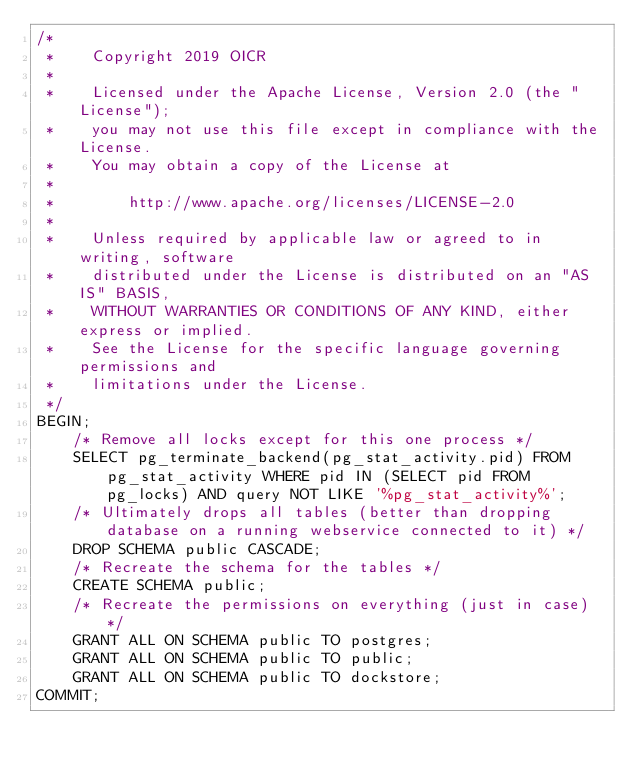<code> <loc_0><loc_0><loc_500><loc_500><_SQL_>/*
 *    Copyright 2019 OICR
 *
 *    Licensed under the Apache License, Version 2.0 (the "License");
 *    you may not use this file except in compliance with the License.
 *    You may obtain a copy of the License at
 *
 *        http://www.apache.org/licenses/LICENSE-2.0
 *
 *    Unless required by applicable law or agreed to in writing, software
 *    distributed under the License is distributed on an "AS IS" BASIS,
 *    WITHOUT WARRANTIES OR CONDITIONS OF ANY KIND, either express or implied.
 *    See the License for the specific language governing permissions and
 *    limitations under the License.
 */
BEGIN;
    /* Remove all locks except for this one process */
    SELECT pg_terminate_backend(pg_stat_activity.pid) FROM pg_stat_activity WHERE pid IN (SELECT pid FROM pg_locks) AND query NOT LIKE '%pg_stat_activity%';
    /* Ultimately drops all tables (better than dropping database on a running webservice connected to it) */
    DROP SCHEMA public CASCADE;
    /* Recreate the schema for the tables */
    CREATE SCHEMA public;
    /* Recreate the permissions on everything (just in case) */
    GRANT ALL ON SCHEMA public TO postgres;
    GRANT ALL ON SCHEMA public TO public;
    GRANT ALL ON SCHEMA public TO dockstore;
COMMIT;
</code> 